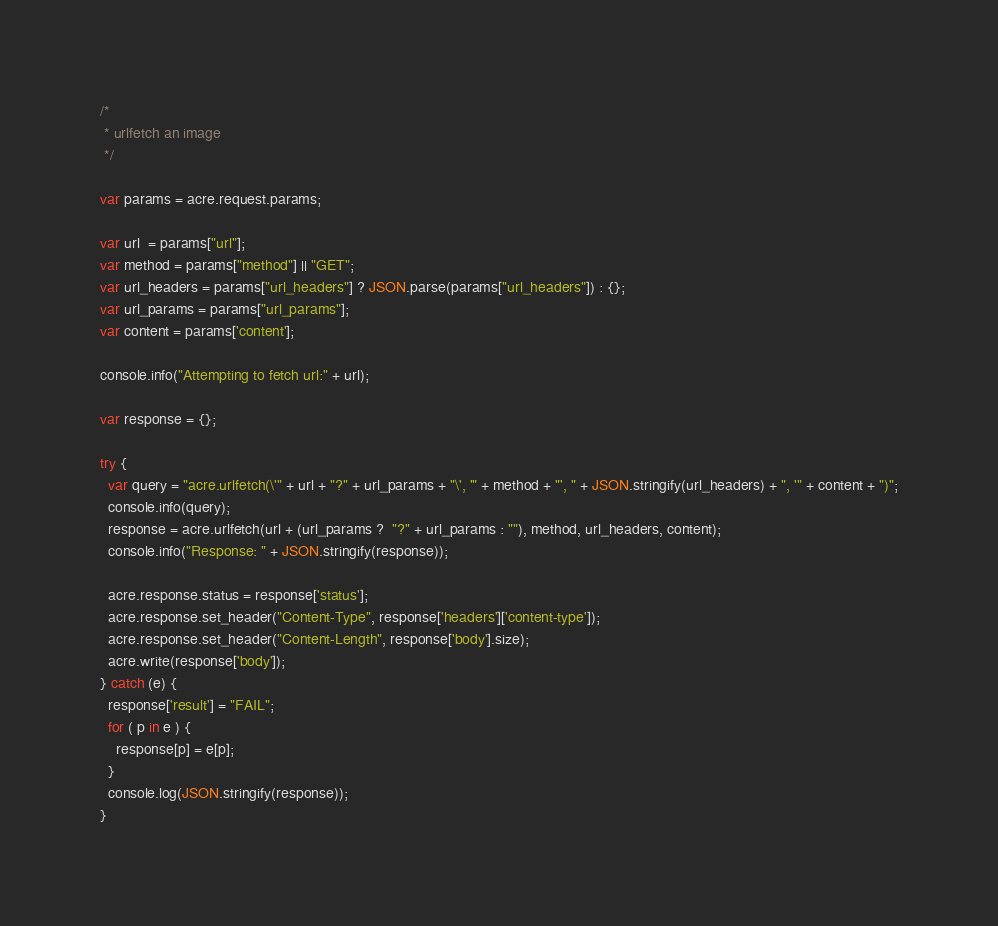<code> <loc_0><loc_0><loc_500><loc_500><_JavaScript_>/*
 * urlfetch an image
 */

var params = acre.request.params;

var url  = params["url"];
var method = params["method"] || "GET";
var url_headers = params["url_headers"] ? JSON.parse(params["url_headers"]) : {};
var url_params = params["url_params"]; 
var content = params['content'];

console.info("Attempting to fetch url:" + url);

var response = {};

try {
  var query = "acre.urlfetch(\'" + url + "?" + url_params + "\', '" + method + "', " + JSON.stringify(url_headers) + ", '" + content + ")";
  console.info(query);
  response = acre.urlfetch(url + (url_params ?  "?" + url_params : ""), method, url_headers, content);
  console.info("Response: " + JSON.stringify(response));

  acre.response.status = response['status'];
  acre.response.set_header("Content-Type", response['headers']['content-type']);
  acre.response.set_header("Content-Length", response['body'].size);
  acre.write(response['body']);
} catch (e) {
  response['result'] = "FAIL";
  for ( p in e ) {
    response[p] = e[p];
  }
  console.log(JSON.stringify(response));
}
</code> 